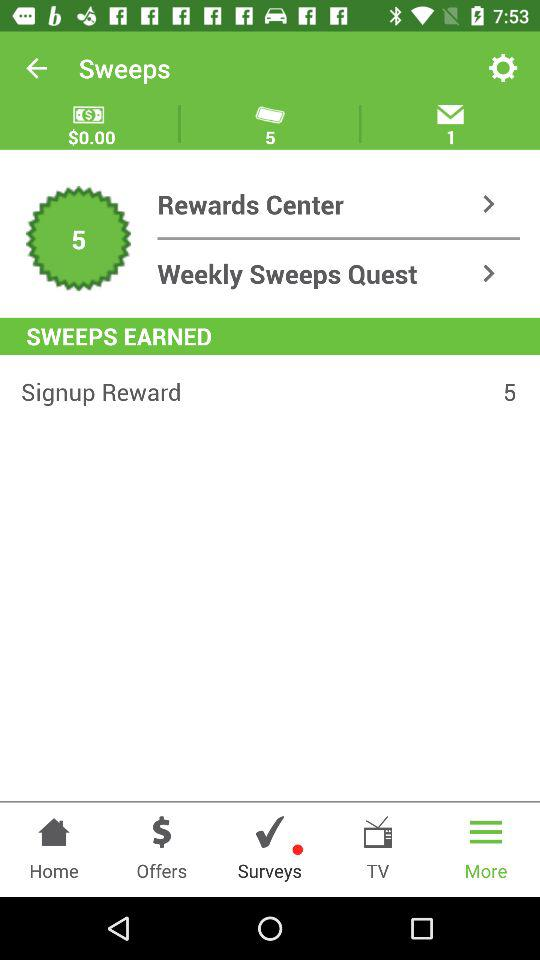Which tab is selected? The selected tab is "More". 